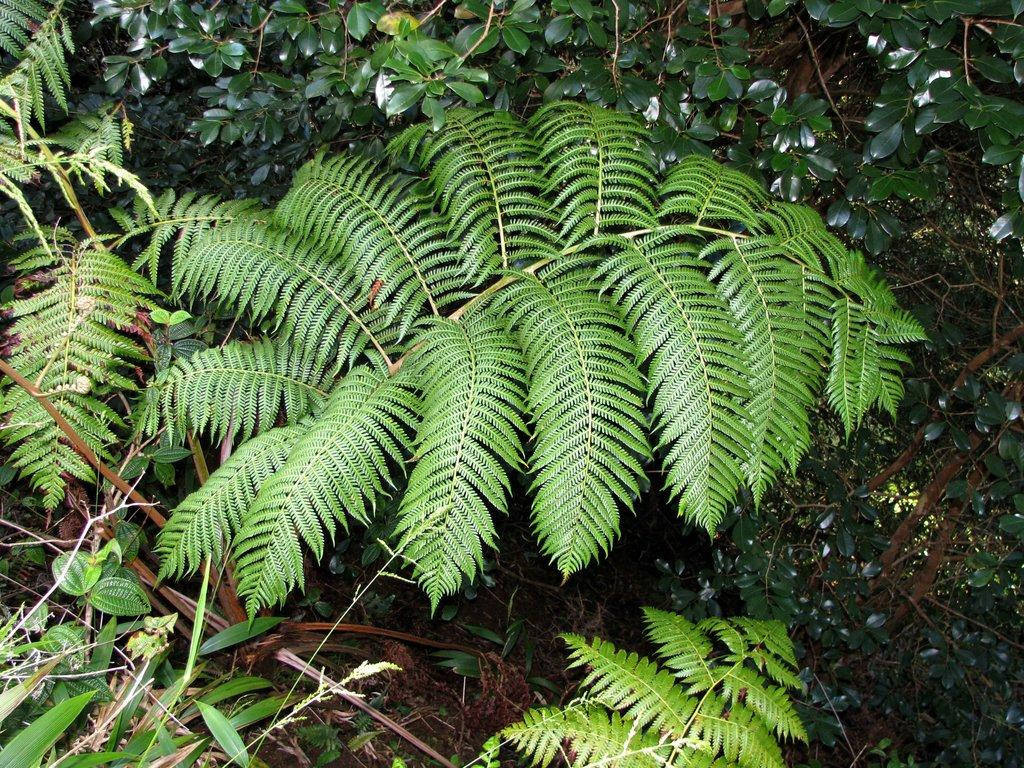What type of living organisms can be seen in the image? Plants can be seen in the image. What type of vegetation is visible in the image? There is grass visible in the image. What type of bubble can be seen in the image? There is no bubble present in the image. What type of office furniture can be seen in the image? There is no office furniture present in the image; it only features plants and grass. 